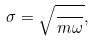<formula> <loc_0><loc_0><loc_500><loc_500>\sigma = \sqrt { \frac { } { m \omega } } ,</formula> 